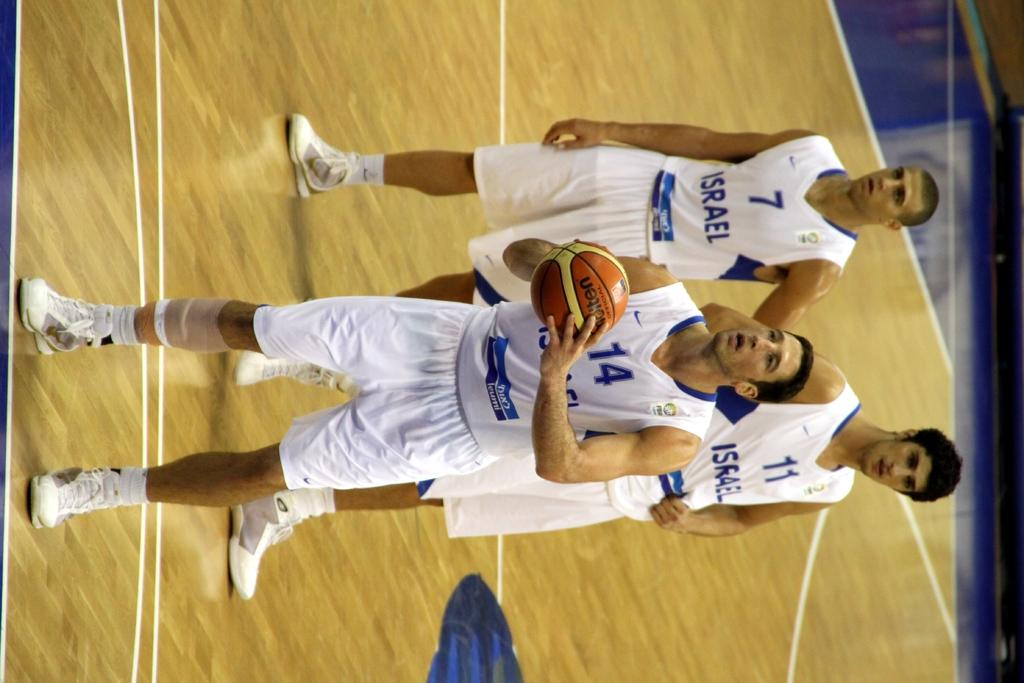<image>
Write a terse but informative summary of the picture. Three players from the israel basketball team are on the court. 